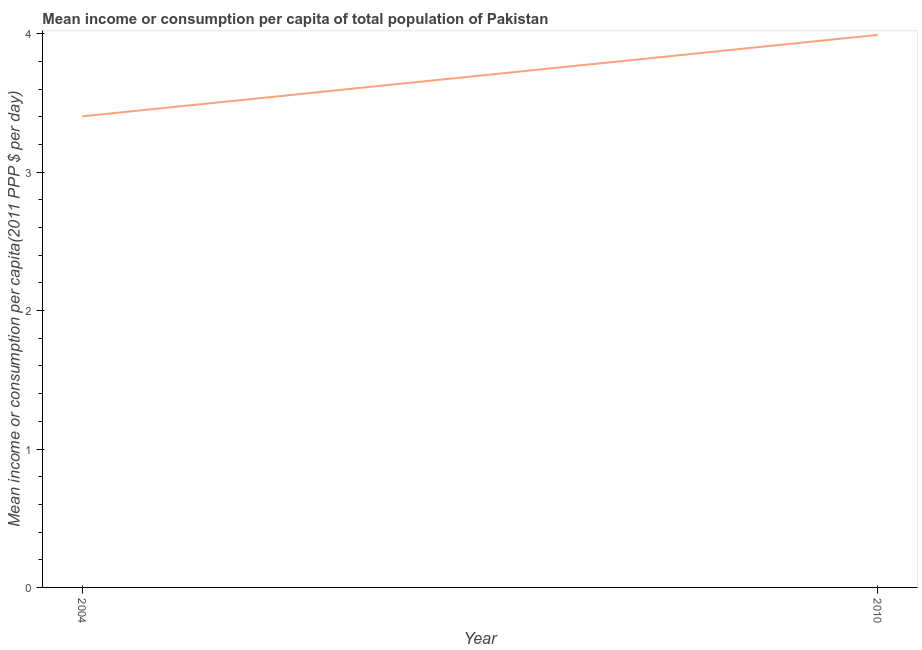What is the mean income or consumption in 2004?
Give a very brief answer. 3.4. Across all years, what is the maximum mean income or consumption?
Your answer should be very brief. 3.99. Across all years, what is the minimum mean income or consumption?
Provide a short and direct response. 3.4. In which year was the mean income or consumption minimum?
Your answer should be very brief. 2004. What is the sum of the mean income or consumption?
Offer a terse response. 7.4. What is the difference between the mean income or consumption in 2004 and 2010?
Keep it short and to the point. -0.59. What is the average mean income or consumption per year?
Offer a terse response. 3.7. What is the median mean income or consumption?
Make the answer very short. 3.7. What is the ratio of the mean income or consumption in 2004 to that in 2010?
Provide a succinct answer. 0.85. Is the mean income or consumption in 2004 less than that in 2010?
Keep it short and to the point. Yes. Does the mean income or consumption monotonically increase over the years?
Give a very brief answer. Yes. How many lines are there?
Offer a terse response. 1. What is the difference between two consecutive major ticks on the Y-axis?
Make the answer very short. 1. Does the graph contain grids?
Your response must be concise. No. What is the title of the graph?
Provide a succinct answer. Mean income or consumption per capita of total population of Pakistan. What is the label or title of the X-axis?
Your answer should be compact. Year. What is the label or title of the Y-axis?
Your answer should be very brief. Mean income or consumption per capita(2011 PPP $ per day). What is the Mean income or consumption per capita(2011 PPP $ per day) in 2004?
Your answer should be compact. 3.4. What is the Mean income or consumption per capita(2011 PPP $ per day) in 2010?
Your response must be concise. 3.99. What is the difference between the Mean income or consumption per capita(2011 PPP $ per day) in 2004 and 2010?
Your answer should be compact. -0.59. What is the ratio of the Mean income or consumption per capita(2011 PPP $ per day) in 2004 to that in 2010?
Your answer should be compact. 0.85. 